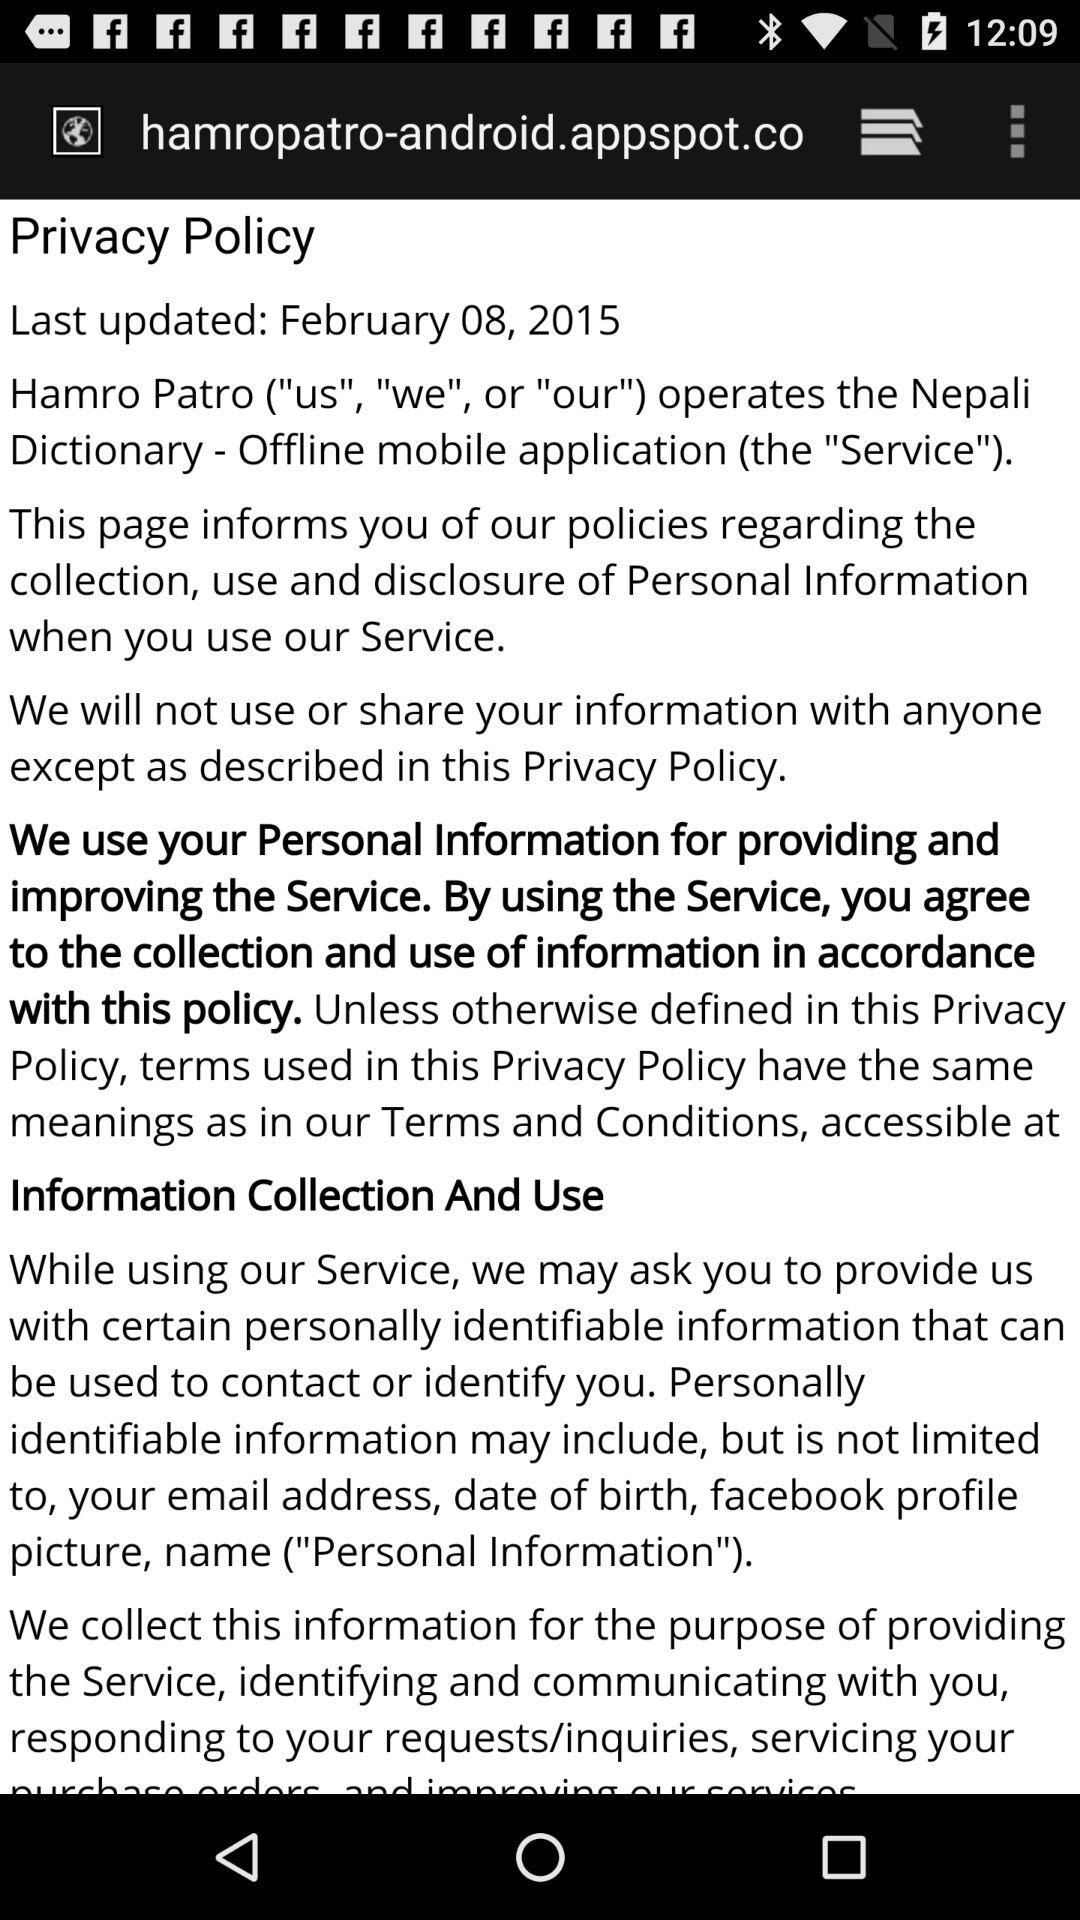When was the policy updated? The policy was updated on February 8, 2015. 